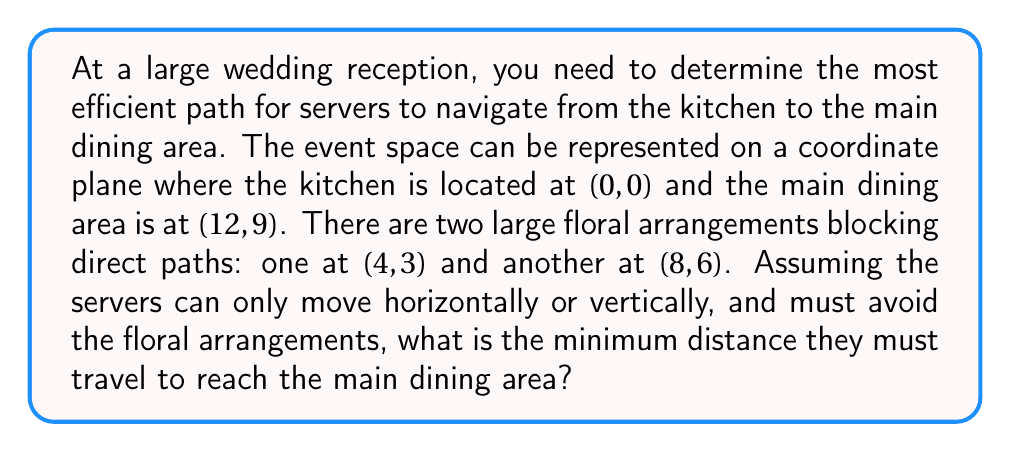Teach me how to tackle this problem. To solve this problem, we need to find the shortest path that avoids the floral arrangements. Let's approach this step-by-step:

1) First, let's visualize the space:

[asy]
unitsize(0.5cm);
draw((0,0)--(12,0)--(12,9)--(0,9)--cycle);
dot((0,0),red);
dot((12,9),blue);
dot((4,3),green);
dot((8,6),green);
label("Kitchen (0,0)", (0,0), SW);
label("Dining (12,9)", (12,9), NE);
label("Floral (4,3)", (4,3), SE);
label("Floral (8,6)", (8,6), NW);
[/asy]

2) The direct path would be blocked by the floral arrangements. We need to find a path around them.

3) There are two possible routes:
   a) Go around the left side of both arrangements
   b) Go between the arrangements

4) For route (a), the path would be:
   (0,0) -> (0,9) -> (12,9)
   Distance = 9 + 12 = 21 units

5) For route (b), we need to go:
   (0,0) -> (4,0) -> (4,6) -> (8,6) -> (8,9) -> (12,9)
   Distance = 4 + 6 + 4 + 3 + 4 = 21 units

6) Both routes have the same distance of 21 units, which is the minimum possible distance avoiding the floral arrangements.

The distance can be calculated using the formula for Manhattan distance:
$$ d = |x_2 - x_1| + |y_2 - y_1| $$

Where $(x_1, y_1)$ is the starting point and $(x_2, y_2)$ is the ending point.
Answer: The minimum distance the servers must travel is 21 units. 